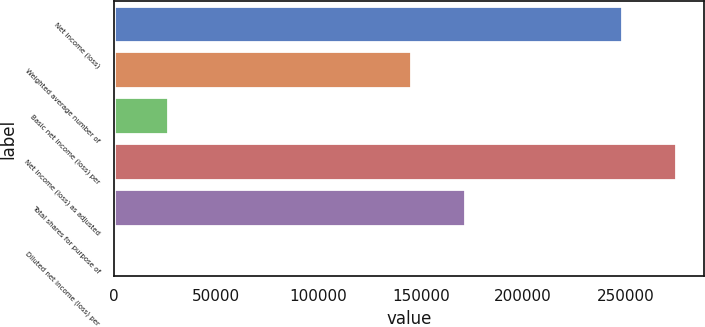<chart> <loc_0><loc_0><loc_500><loc_500><bar_chart><fcel>Net income (loss)<fcel>Weighted average number of<fcel>Basic net income (loss) per<fcel>Net income (loss) as adjusted<fcel>Total shares for purpose of<fcel>Diluted net income (loss) per<nl><fcel>248438<fcel>145395<fcel>26284.5<fcel>274721<fcel>171678<fcel>1.54<nl></chart> 